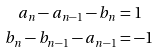<formula> <loc_0><loc_0><loc_500><loc_500>a _ { n } - a _ { n - 1 } - b _ { n } & = 1 \\ b _ { n } - b _ { n - 1 } - a _ { n - 1 } & = - 1</formula> 